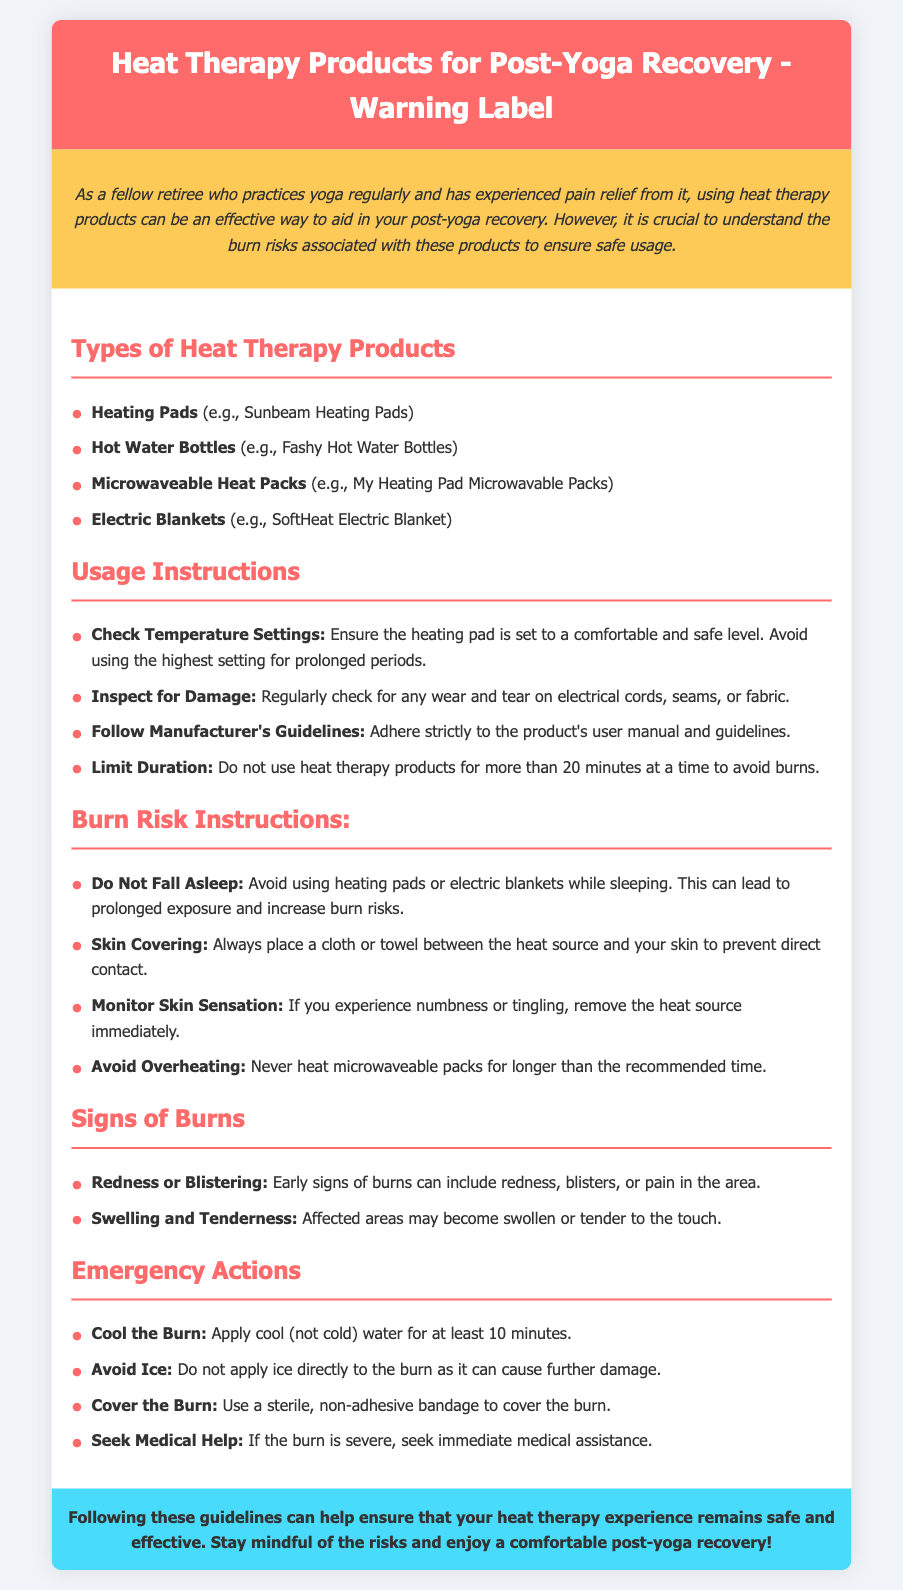What are the types of heat therapy products? The document lists four types of heat therapy products: Heating Pads, Hot Water Bottles, Microwaveable Heat Packs, and Electric Blankets.
Answer: Heating Pads, Hot Water Bottles, Microwaveable Heat Packs, Electric Blankets What is the maximum duration for using heat therapy products at a time? The document states that heat therapy products should not be used for more than 20 minutes at a time to avoid burns.
Answer: 20 minutes What should you place between the heat source and your skin? The document advises placing a cloth or towel between the heat source and your skin to prevent direct contact.
Answer: A cloth or towel What is a sign of burns according to the document? The document mentions redness, blisters, or pain as early signs of burns.
Answer: Redness or Blistering What action should be taken if experiencing numbness or tingling? The document instructs to remove the heat source immediately if numbness or tingling occurs.
Answer: Remove the heat source immediately What should be avoided while using heating pads or electric blankets? The document warns not to fall asleep while using heating pads or electric blankets due to increased burn risks.
Answer: Fall asleep What should you do to cool a burn? The document recommends applying cool (not cold) water for at least 10 minutes to cool a burn.
Answer: Apply cool water What type of bandage should be used to cover a burn? The document specifies using a sterile, non-adhesive bandage to cover the burn.
Answer: Sterile, non-adhesive bandage 